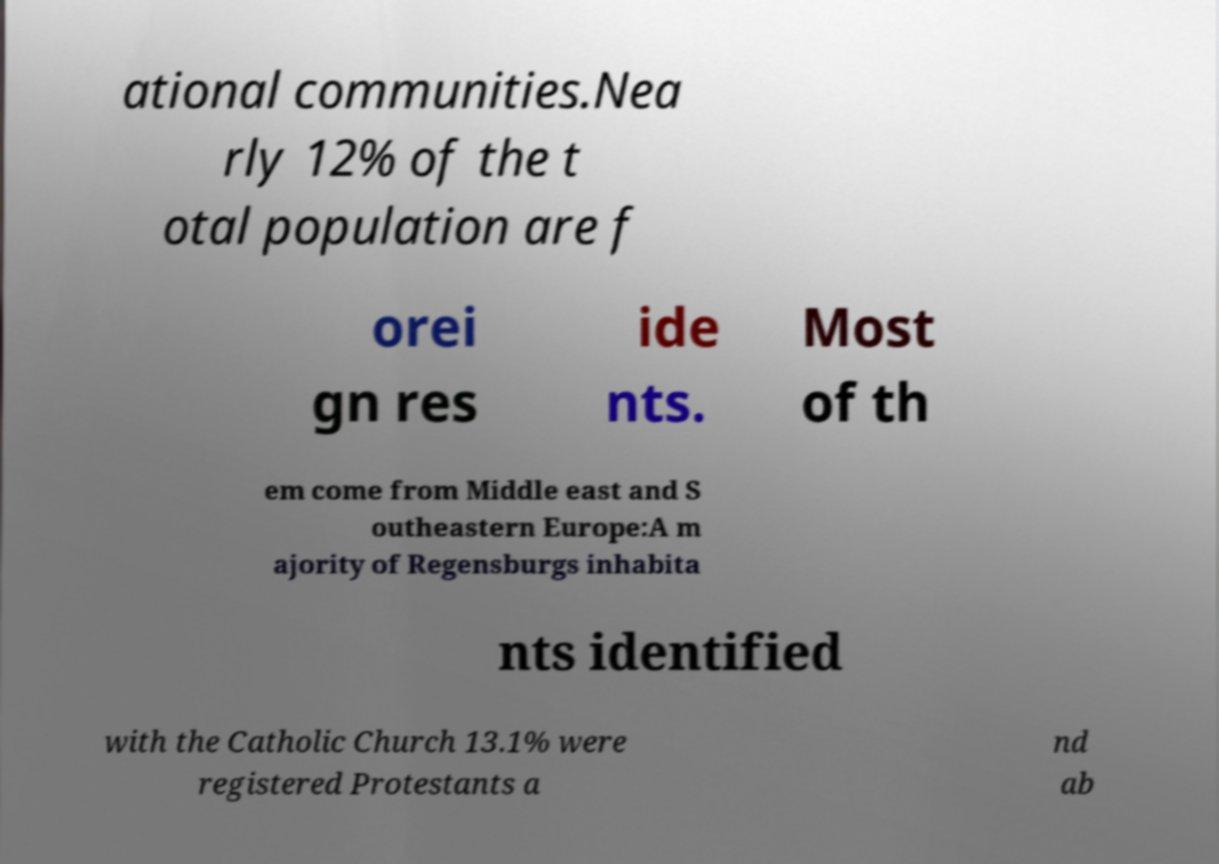What messages or text are displayed in this image? I need them in a readable, typed format. ational communities.Nea rly 12% of the t otal population are f orei gn res ide nts. Most of th em come from Middle east and S outheastern Europe:A m ajority of Regensburgs inhabita nts identified with the Catholic Church 13.1% were registered Protestants a nd ab 